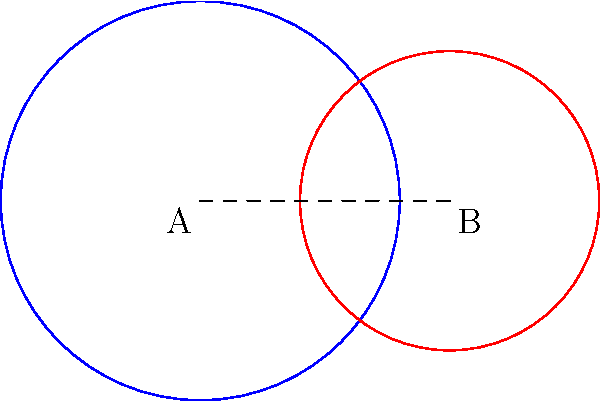Two circular folk art patterns on a traditional Slovak kroj (folk costume) from Detva overlap as shown in the diagram. The blue circle has a radius of 4 cm and the red circle has a radius of 3 cm. If the centers of the circles are 5 cm apart, what is the area of the overlapping region in square centimeters? To find the area of overlap between two circles, we can use the following steps:

1. Calculate the distance $d$ between the centers of the circles:
   $d = 5$ cm (given in the question)

2. Check if the circles intersect:
   $r_1 + r_2 > d > |r_1 - r_2|$
   $7 > 5 > 1$, so they do intersect.

3. Calculate the angles $\theta_1$ and $\theta_2$:
   $\theta_1 = 2 \arccos(\frac{d^2 + r_1^2 - r_2^2}{2dr_1})$
   $\theta_2 = 2 \arccos(\frac{d^2 + r_2^2 - r_1^2}{2dr_2})$

   $\theta_1 = 2 \arccos(\frac{5^2 + 4^2 - 3^2}{2 \cdot 5 \cdot 4}) \approx 1.8735$ radians
   $\theta_2 = 2 \arccos(\frac{5^2 + 3^2 - 4^2}{2 \cdot 5 \cdot 3}) \approx 2.0944$ radians

4. Calculate the areas of the circular sectors:
   $A_1 = \frac{1}{2} r_1^2 \theta_1 \approx 14.9880$ cm²
   $A_2 = \frac{1}{2} r_2^2 \theta_2 \approx 9.4248$ cm²

5. Calculate the areas of the triangles:
   $A_{t1} = \frac{1}{2} r_1^2 \sin(\theta_1) \approx 7.1291$ cm²
   $A_{t2} = \frac{1}{2} r_2^2 \sin(\theta_2) \approx 4.3301$ cm²

6. Calculate the area of overlap:
   $A_{overlap} = A_1 + A_2 - A_{t1} - A_{t2}$
   $A_{overlap} \approx 14.9880 + 9.4248 - 7.1291 - 4.3301 \approx 12.9536$ cm²

Therefore, the area of the overlapping region is approximately 12.95 cm².
Answer: 12.95 cm² 